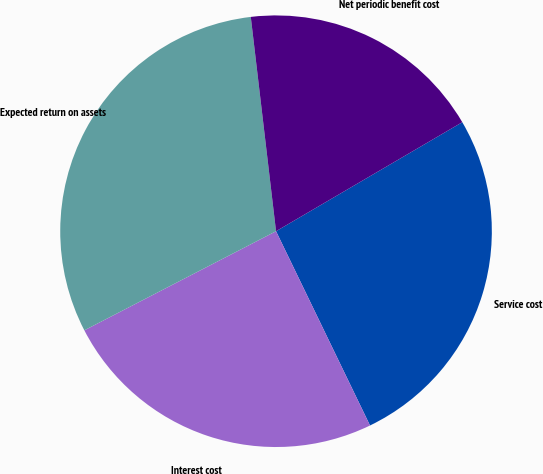Convert chart. <chart><loc_0><loc_0><loc_500><loc_500><pie_chart><fcel>Service cost<fcel>Interest cost<fcel>Expected return on assets<fcel>Net periodic benefit cost<nl><fcel>26.26%<fcel>24.58%<fcel>30.73%<fcel>18.44%<nl></chart> 